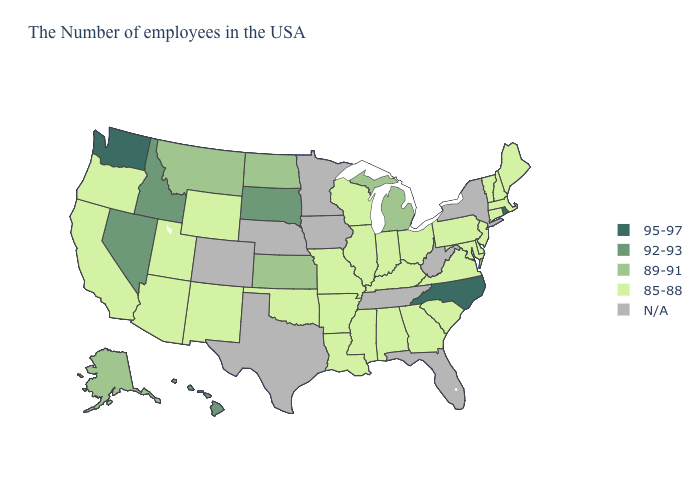Name the states that have a value in the range N/A?
Give a very brief answer. New York, West Virginia, Florida, Tennessee, Minnesota, Iowa, Nebraska, Texas, Colorado. Name the states that have a value in the range 89-91?
Quick response, please. Michigan, Kansas, North Dakota, Montana, Alaska. What is the value of New Jersey?
Quick response, please. 85-88. What is the lowest value in the South?
Answer briefly. 85-88. Which states have the highest value in the USA?
Give a very brief answer. Rhode Island, North Carolina, Washington. What is the highest value in the MidWest ?
Short answer required. 92-93. What is the value of Kentucky?
Write a very short answer. 85-88. Does Maryland have the lowest value in the USA?
Write a very short answer. Yes. Does Ohio have the lowest value in the MidWest?
Answer briefly. Yes. Does the map have missing data?
Be succinct. Yes. Which states have the lowest value in the USA?
Answer briefly. Maine, Massachusetts, New Hampshire, Vermont, Connecticut, New Jersey, Delaware, Maryland, Pennsylvania, Virginia, South Carolina, Ohio, Georgia, Kentucky, Indiana, Alabama, Wisconsin, Illinois, Mississippi, Louisiana, Missouri, Arkansas, Oklahoma, Wyoming, New Mexico, Utah, Arizona, California, Oregon. Name the states that have a value in the range 92-93?
Answer briefly. South Dakota, Idaho, Nevada, Hawaii. Name the states that have a value in the range 89-91?
Write a very short answer. Michigan, Kansas, North Dakota, Montana, Alaska. Name the states that have a value in the range 95-97?
Answer briefly. Rhode Island, North Carolina, Washington. 